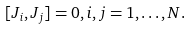Convert formula to latex. <formula><loc_0><loc_0><loc_500><loc_500>[ J _ { i } , J _ { j } ] = 0 , i , j = 1 , \dots , N .</formula> 